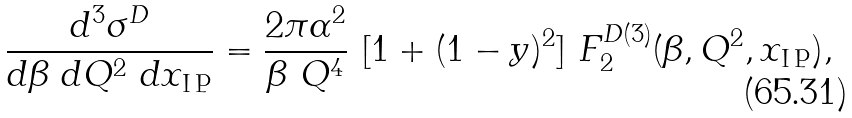<formula> <loc_0><loc_0><loc_500><loc_500>\frac { d ^ { 3 } \sigma ^ { D } } { d { \beta } \ d Q ^ { 2 } \ d x _ { \tt I \, P } } = \frac { 2 \pi \alpha ^ { 2 } } { \beta \ Q ^ { 4 } } \ [ 1 + ( 1 - y ) ^ { 2 } ] \ F ^ { D ( 3 ) } _ { 2 } ( \beta , Q ^ { 2 } , x _ { \tt I \, P } ) ,</formula> 